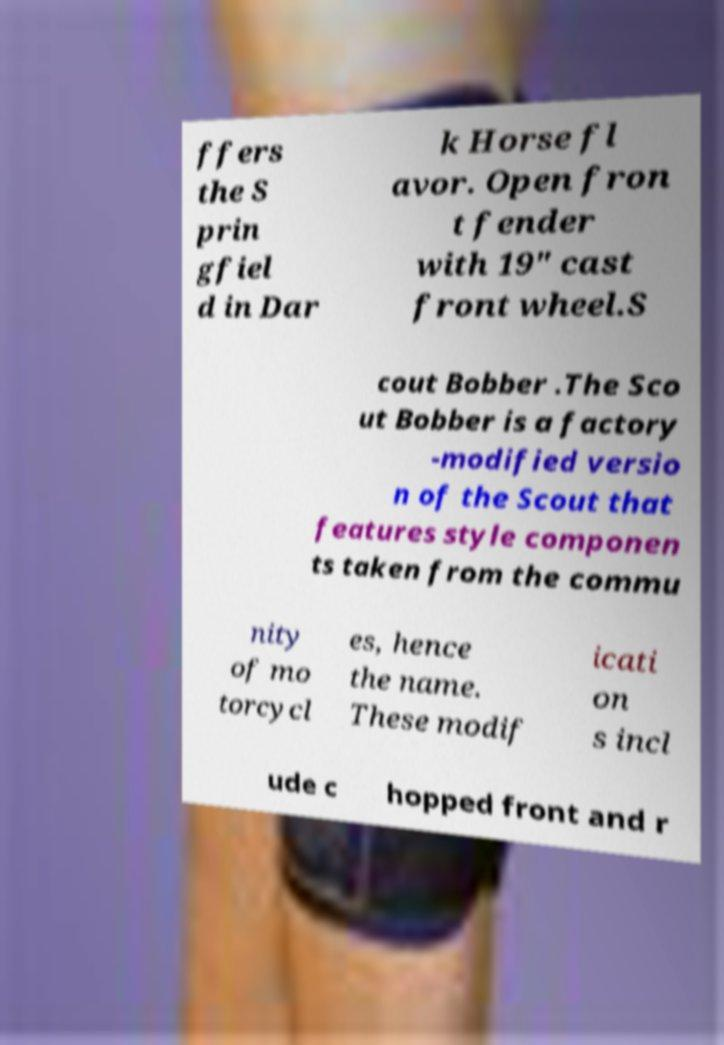Could you assist in decoding the text presented in this image and type it out clearly? ffers the S prin gfiel d in Dar k Horse fl avor. Open fron t fender with 19" cast front wheel.S cout Bobber .The Sco ut Bobber is a factory -modified versio n of the Scout that features style componen ts taken from the commu nity of mo torcycl es, hence the name. These modif icati on s incl ude c hopped front and r 